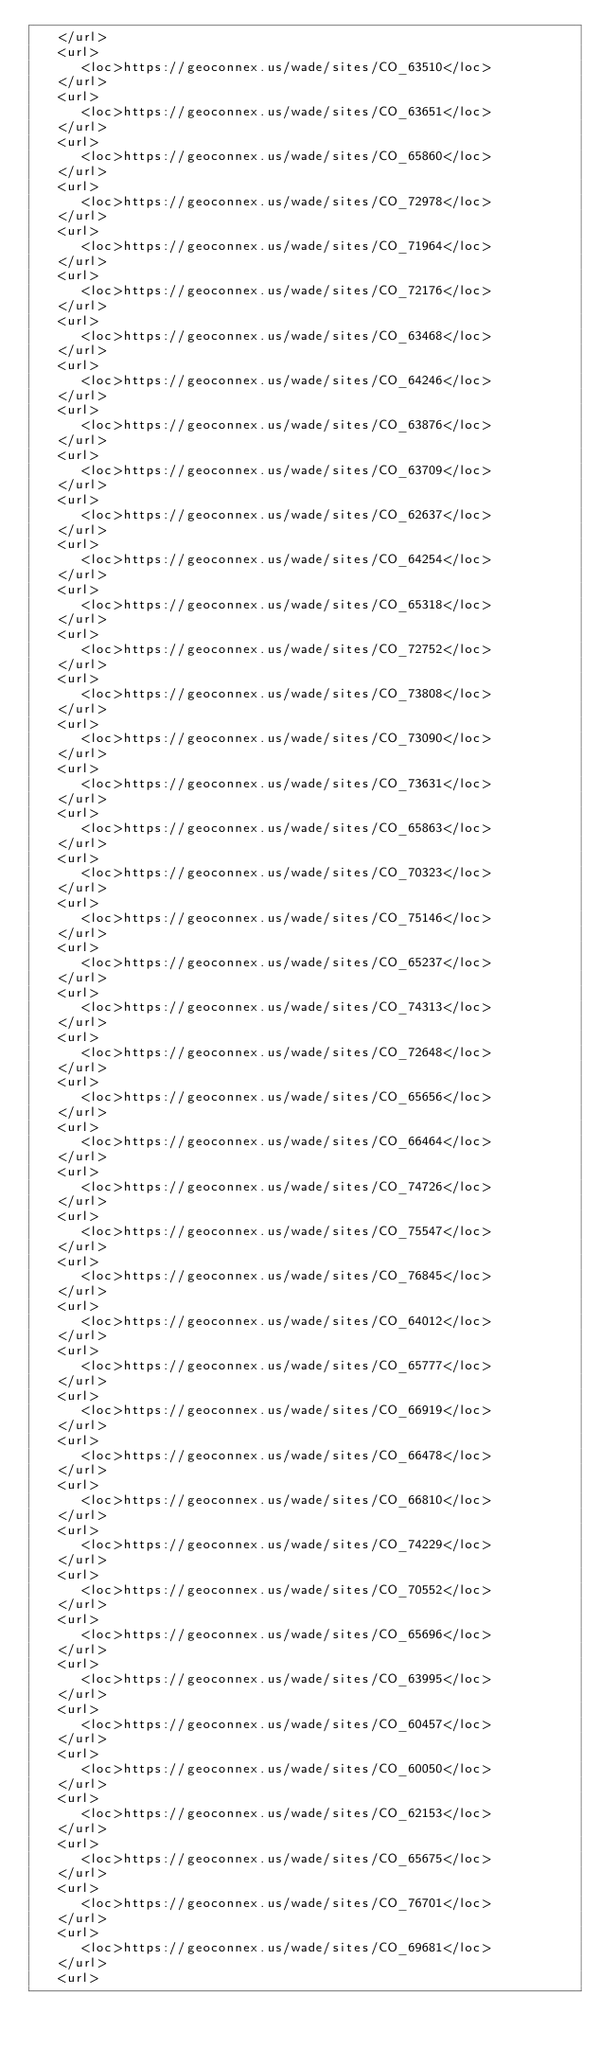<code> <loc_0><loc_0><loc_500><loc_500><_XML_>   </url>
   <url>
      <loc>https://geoconnex.us/wade/sites/CO_63510</loc>
   </url>
   <url>
      <loc>https://geoconnex.us/wade/sites/CO_63651</loc>
   </url>
   <url>
      <loc>https://geoconnex.us/wade/sites/CO_65860</loc>
   </url>
   <url>
      <loc>https://geoconnex.us/wade/sites/CO_72978</loc>
   </url>
   <url>
      <loc>https://geoconnex.us/wade/sites/CO_71964</loc>
   </url>
   <url>
      <loc>https://geoconnex.us/wade/sites/CO_72176</loc>
   </url>
   <url>
      <loc>https://geoconnex.us/wade/sites/CO_63468</loc>
   </url>
   <url>
      <loc>https://geoconnex.us/wade/sites/CO_64246</loc>
   </url>
   <url>
      <loc>https://geoconnex.us/wade/sites/CO_63876</loc>
   </url>
   <url>
      <loc>https://geoconnex.us/wade/sites/CO_63709</loc>
   </url>
   <url>
      <loc>https://geoconnex.us/wade/sites/CO_62637</loc>
   </url>
   <url>
      <loc>https://geoconnex.us/wade/sites/CO_64254</loc>
   </url>
   <url>
      <loc>https://geoconnex.us/wade/sites/CO_65318</loc>
   </url>
   <url>
      <loc>https://geoconnex.us/wade/sites/CO_72752</loc>
   </url>
   <url>
      <loc>https://geoconnex.us/wade/sites/CO_73808</loc>
   </url>
   <url>
      <loc>https://geoconnex.us/wade/sites/CO_73090</loc>
   </url>
   <url>
      <loc>https://geoconnex.us/wade/sites/CO_73631</loc>
   </url>
   <url>
      <loc>https://geoconnex.us/wade/sites/CO_65863</loc>
   </url>
   <url>
      <loc>https://geoconnex.us/wade/sites/CO_70323</loc>
   </url>
   <url>
      <loc>https://geoconnex.us/wade/sites/CO_75146</loc>
   </url>
   <url>
      <loc>https://geoconnex.us/wade/sites/CO_65237</loc>
   </url>
   <url>
      <loc>https://geoconnex.us/wade/sites/CO_74313</loc>
   </url>
   <url>
      <loc>https://geoconnex.us/wade/sites/CO_72648</loc>
   </url>
   <url>
      <loc>https://geoconnex.us/wade/sites/CO_65656</loc>
   </url>
   <url>
      <loc>https://geoconnex.us/wade/sites/CO_66464</loc>
   </url>
   <url>
      <loc>https://geoconnex.us/wade/sites/CO_74726</loc>
   </url>
   <url>
      <loc>https://geoconnex.us/wade/sites/CO_75547</loc>
   </url>
   <url>
      <loc>https://geoconnex.us/wade/sites/CO_76845</loc>
   </url>
   <url>
      <loc>https://geoconnex.us/wade/sites/CO_64012</loc>
   </url>
   <url>
      <loc>https://geoconnex.us/wade/sites/CO_65777</loc>
   </url>
   <url>
      <loc>https://geoconnex.us/wade/sites/CO_66919</loc>
   </url>
   <url>
      <loc>https://geoconnex.us/wade/sites/CO_66478</loc>
   </url>
   <url>
      <loc>https://geoconnex.us/wade/sites/CO_66810</loc>
   </url>
   <url>
      <loc>https://geoconnex.us/wade/sites/CO_74229</loc>
   </url>
   <url>
      <loc>https://geoconnex.us/wade/sites/CO_70552</loc>
   </url>
   <url>
      <loc>https://geoconnex.us/wade/sites/CO_65696</loc>
   </url>
   <url>
      <loc>https://geoconnex.us/wade/sites/CO_63995</loc>
   </url>
   <url>
      <loc>https://geoconnex.us/wade/sites/CO_60457</loc>
   </url>
   <url>
      <loc>https://geoconnex.us/wade/sites/CO_60050</loc>
   </url>
   <url>
      <loc>https://geoconnex.us/wade/sites/CO_62153</loc>
   </url>
   <url>
      <loc>https://geoconnex.us/wade/sites/CO_65675</loc>
   </url>
   <url>
      <loc>https://geoconnex.us/wade/sites/CO_76701</loc>
   </url>
   <url>
      <loc>https://geoconnex.us/wade/sites/CO_69681</loc>
   </url>
   <url></code> 